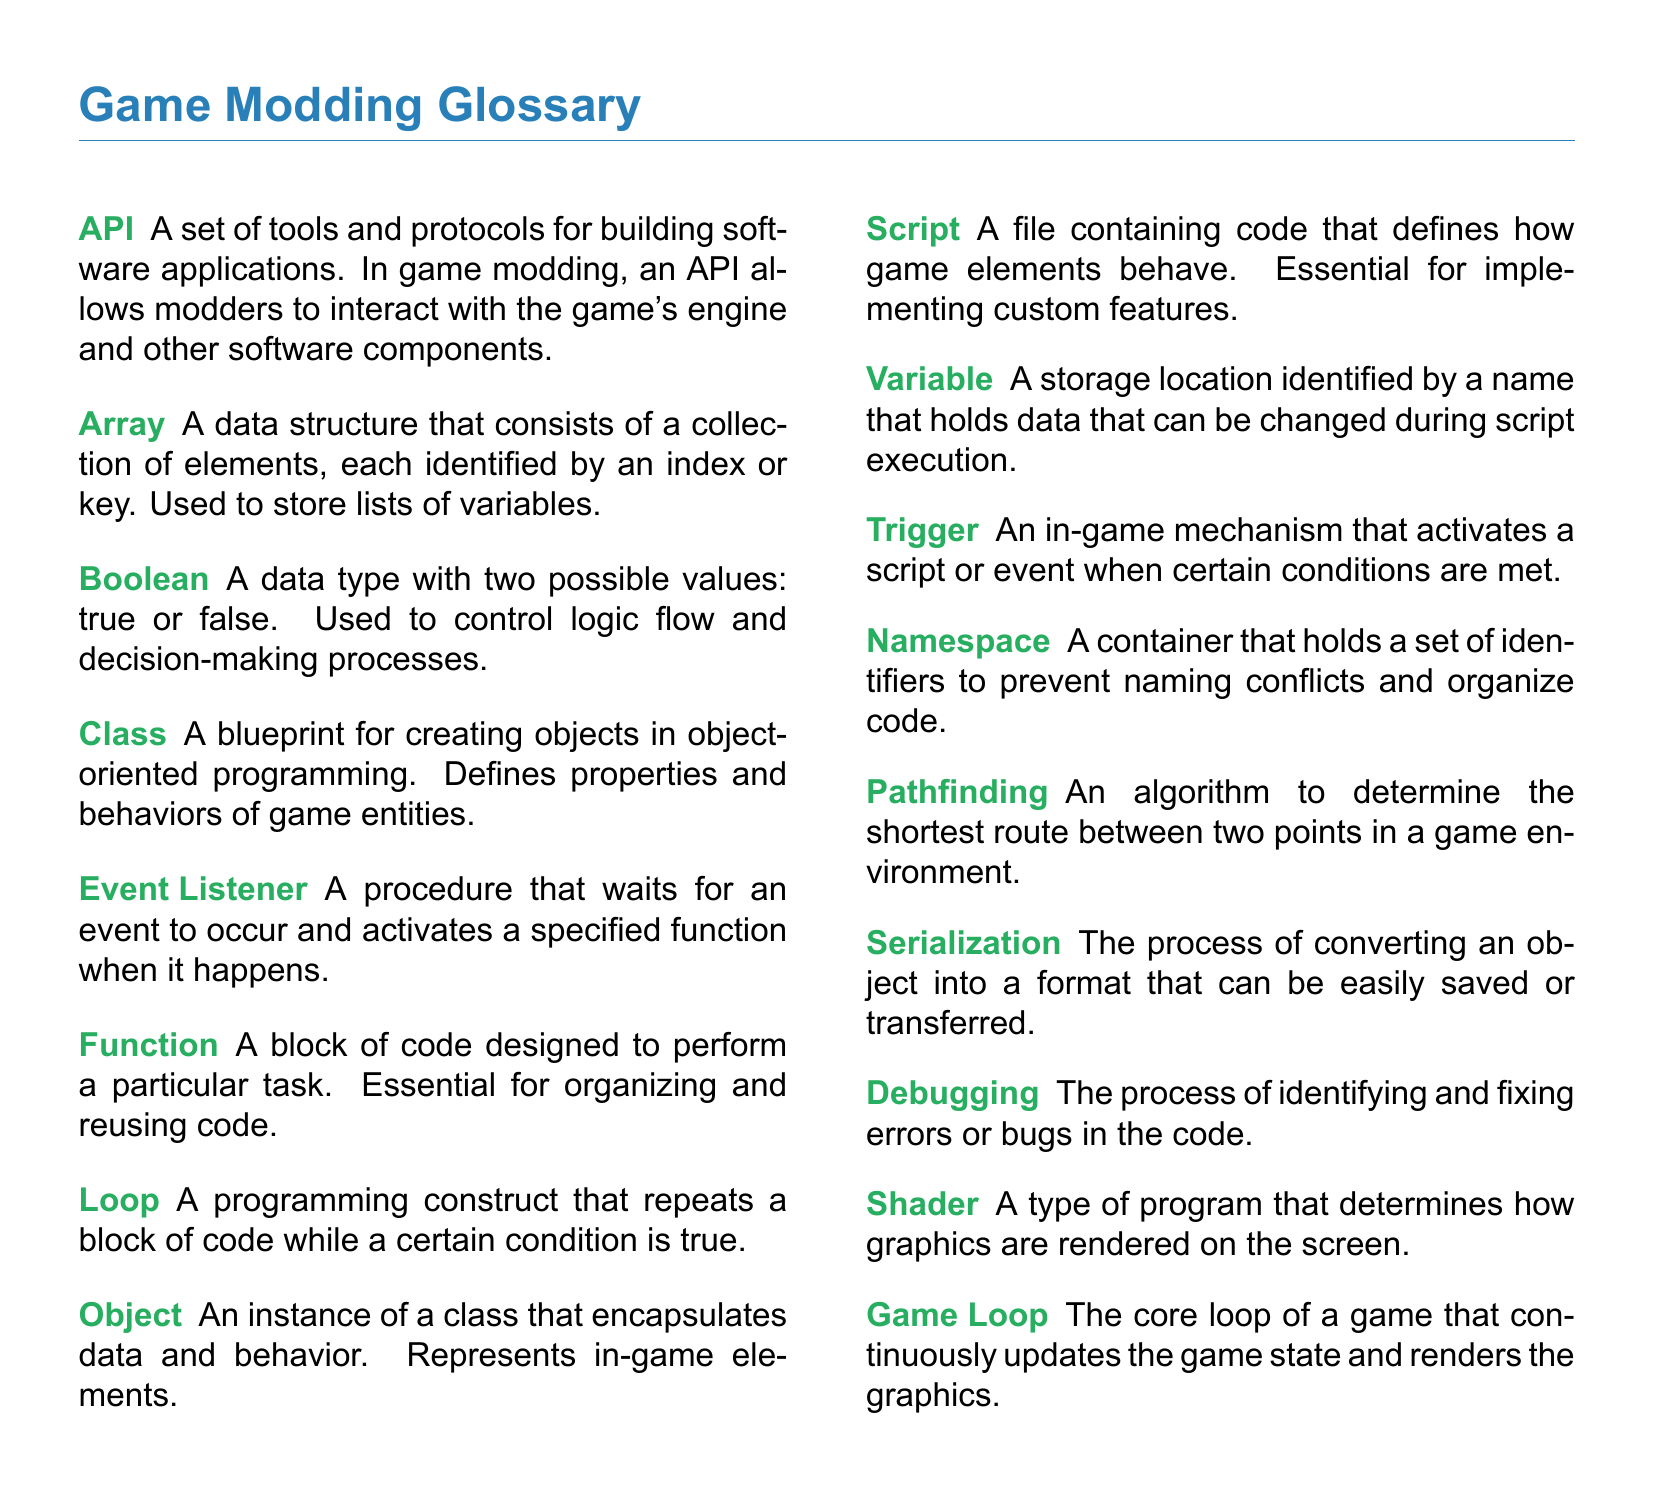What is an API? An API is a set of tools and protocols for building software applications that allows modders to interact with the game's engine.
Answer: A set of tools and protocols What data type has two possible values? The document states that a Boolean is a data type with two possible values, true or false.
Answer: Boolean What defines properties and behaviors of game entities? A class serves as a blueprint for creating objects, defining their properties and behaviors.
Answer: Class What is the purpose of a function in coding? A function is designed to perform a particular task, helping to organize and reuse code effectively.
Answer: To perform a particular task What does serialization do? Serialization converts an object into a format that can be easily saved or transferred.
Answer: Converts an object What does an event listener do? An event listener waits for an event to occur and activates a specified function in response.
Answer: Activates a specified function What is the document type of this text? The text is categorized as a glossary, which includes definitions of key terms related to game scripting.
Answer: Glossary How many key terms are listed in the document? There are 15 key terms provided in the glossary section of the document.
Answer: 15 What algorithm is mentioned in the document related to game environments? The document refers to pathfinding as the algorithm used to determine the shortest route between two points.
Answer: Pathfinding 